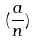Convert formula to latex. <formula><loc_0><loc_0><loc_500><loc_500>( \frac { a } { n } )</formula> 